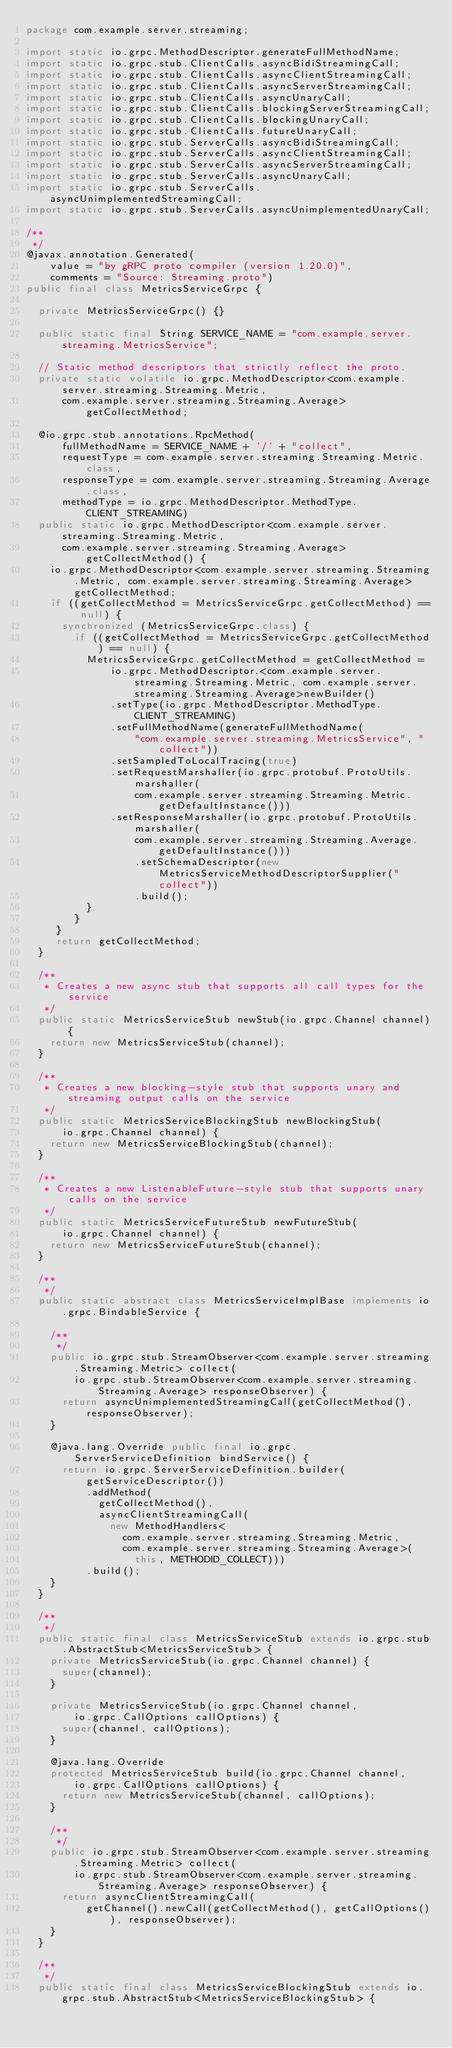Convert code to text. <code><loc_0><loc_0><loc_500><loc_500><_Java_>package com.example.server.streaming;

import static io.grpc.MethodDescriptor.generateFullMethodName;
import static io.grpc.stub.ClientCalls.asyncBidiStreamingCall;
import static io.grpc.stub.ClientCalls.asyncClientStreamingCall;
import static io.grpc.stub.ClientCalls.asyncServerStreamingCall;
import static io.grpc.stub.ClientCalls.asyncUnaryCall;
import static io.grpc.stub.ClientCalls.blockingServerStreamingCall;
import static io.grpc.stub.ClientCalls.blockingUnaryCall;
import static io.grpc.stub.ClientCalls.futureUnaryCall;
import static io.grpc.stub.ServerCalls.asyncBidiStreamingCall;
import static io.grpc.stub.ServerCalls.asyncClientStreamingCall;
import static io.grpc.stub.ServerCalls.asyncServerStreamingCall;
import static io.grpc.stub.ServerCalls.asyncUnaryCall;
import static io.grpc.stub.ServerCalls.asyncUnimplementedStreamingCall;
import static io.grpc.stub.ServerCalls.asyncUnimplementedUnaryCall;

/**
 */
@javax.annotation.Generated(
    value = "by gRPC proto compiler (version 1.20.0)",
    comments = "Source: Streaming.proto")
public final class MetricsServiceGrpc {

  private MetricsServiceGrpc() {}

  public static final String SERVICE_NAME = "com.example.server.streaming.MetricsService";

  // Static method descriptors that strictly reflect the proto.
  private static volatile io.grpc.MethodDescriptor<com.example.server.streaming.Streaming.Metric,
      com.example.server.streaming.Streaming.Average> getCollectMethod;

  @io.grpc.stub.annotations.RpcMethod(
      fullMethodName = SERVICE_NAME + '/' + "collect",
      requestType = com.example.server.streaming.Streaming.Metric.class,
      responseType = com.example.server.streaming.Streaming.Average.class,
      methodType = io.grpc.MethodDescriptor.MethodType.CLIENT_STREAMING)
  public static io.grpc.MethodDescriptor<com.example.server.streaming.Streaming.Metric,
      com.example.server.streaming.Streaming.Average> getCollectMethod() {
    io.grpc.MethodDescriptor<com.example.server.streaming.Streaming.Metric, com.example.server.streaming.Streaming.Average> getCollectMethod;
    if ((getCollectMethod = MetricsServiceGrpc.getCollectMethod) == null) {
      synchronized (MetricsServiceGrpc.class) {
        if ((getCollectMethod = MetricsServiceGrpc.getCollectMethod) == null) {
          MetricsServiceGrpc.getCollectMethod = getCollectMethod = 
              io.grpc.MethodDescriptor.<com.example.server.streaming.Streaming.Metric, com.example.server.streaming.Streaming.Average>newBuilder()
              .setType(io.grpc.MethodDescriptor.MethodType.CLIENT_STREAMING)
              .setFullMethodName(generateFullMethodName(
                  "com.example.server.streaming.MetricsService", "collect"))
              .setSampledToLocalTracing(true)
              .setRequestMarshaller(io.grpc.protobuf.ProtoUtils.marshaller(
                  com.example.server.streaming.Streaming.Metric.getDefaultInstance()))
              .setResponseMarshaller(io.grpc.protobuf.ProtoUtils.marshaller(
                  com.example.server.streaming.Streaming.Average.getDefaultInstance()))
                  .setSchemaDescriptor(new MetricsServiceMethodDescriptorSupplier("collect"))
                  .build();
          }
        }
     }
     return getCollectMethod;
  }

  /**
   * Creates a new async stub that supports all call types for the service
   */
  public static MetricsServiceStub newStub(io.grpc.Channel channel) {
    return new MetricsServiceStub(channel);
  }

  /**
   * Creates a new blocking-style stub that supports unary and streaming output calls on the service
   */
  public static MetricsServiceBlockingStub newBlockingStub(
      io.grpc.Channel channel) {
    return new MetricsServiceBlockingStub(channel);
  }

  /**
   * Creates a new ListenableFuture-style stub that supports unary calls on the service
   */
  public static MetricsServiceFutureStub newFutureStub(
      io.grpc.Channel channel) {
    return new MetricsServiceFutureStub(channel);
  }

  /**
   */
  public static abstract class MetricsServiceImplBase implements io.grpc.BindableService {

    /**
     */
    public io.grpc.stub.StreamObserver<com.example.server.streaming.Streaming.Metric> collect(
        io.grpc.stub.StreamObserver<com.example.server.streaming.Streaming.Average> responseObserver) {
      return asyncUnimplementedStreamingCall(getCollectMethod(), responseObserver);
    }

    @java.lang.Override public final io.grpc.ServerServiceDefinition bindService() {
      return io.grpc.ServerServiceDefinition.builder(getServiceDescriptor())
          .addMethod(
            getCollectMethod(),
            asyncClientStreamingCall(
              new MethodHandlers<
                com.example.server.streaming.Streaming.Metric,
                com.example.server.streaming.Streaming.Average>(
                  this, METHODID_COLLECT)))
          .build();
    }
  }

  /**
   */
  public static final class MetricsServiceStub extends io.grpc.stub.AbstractStub<MetricsServiceStub> {
    private MetricsServiceStub(io.grpc.Channel channel) {
      super(channel);
    }

    private MetricsServiceStub(io.grpc.Channel channel,
        io.grpc.CallOptions callOptions) {
      super(channel, callOptions);
    }

    @java.lang.Override
    protected MetricsServiceStub build(io.grpc.Channel channel,
        io.grpc.CallOptions callOptions) {
      return new MetricsServiceStub(channel, callOptions);
    }

    /**
     */
    public io.grpc.stub.StreamObserver<com.example.server.streaming.Streaming.Metric> collect(
        io.grpc.stub.StreamObserver<com.example.server.streaming.Streaming.Average> responseObserver) {
      return asyncClientStreamingCall(
          getChannel().newCall(getCollectMethod(), getCallOptions()), responseObserver);
    }
  }

  /**
   */
  public static final class MetricsServiceBlockingStub extends io.grpc.stub.AbstractStub<MetricsServiceBlockingStub> {</code> 